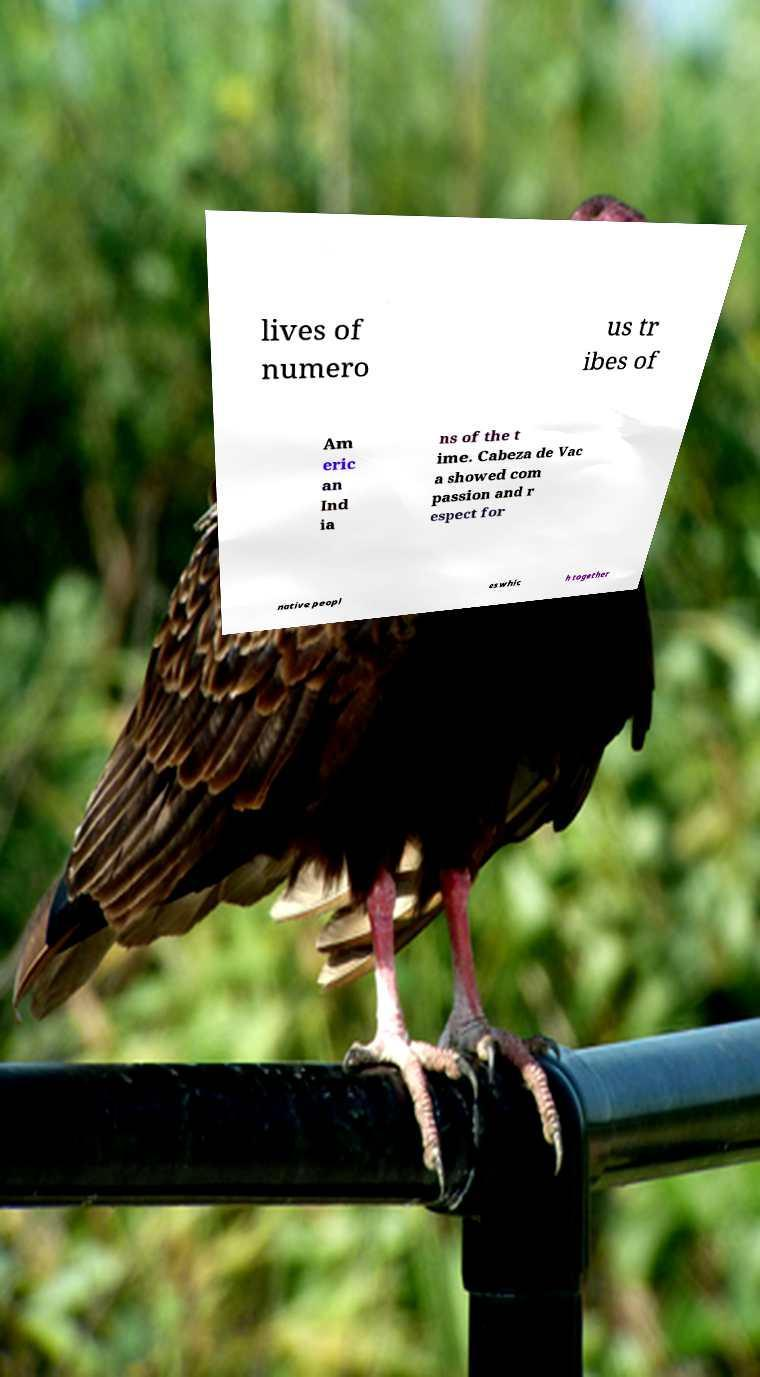Could you assist in decoding the text presented in this image and type it out clearly? lives of numero us tr ibes of Am eric an Ind ia ns of the t ime. Cabeza de Vac a showed com passion and r espect for native peopl es whic h together 